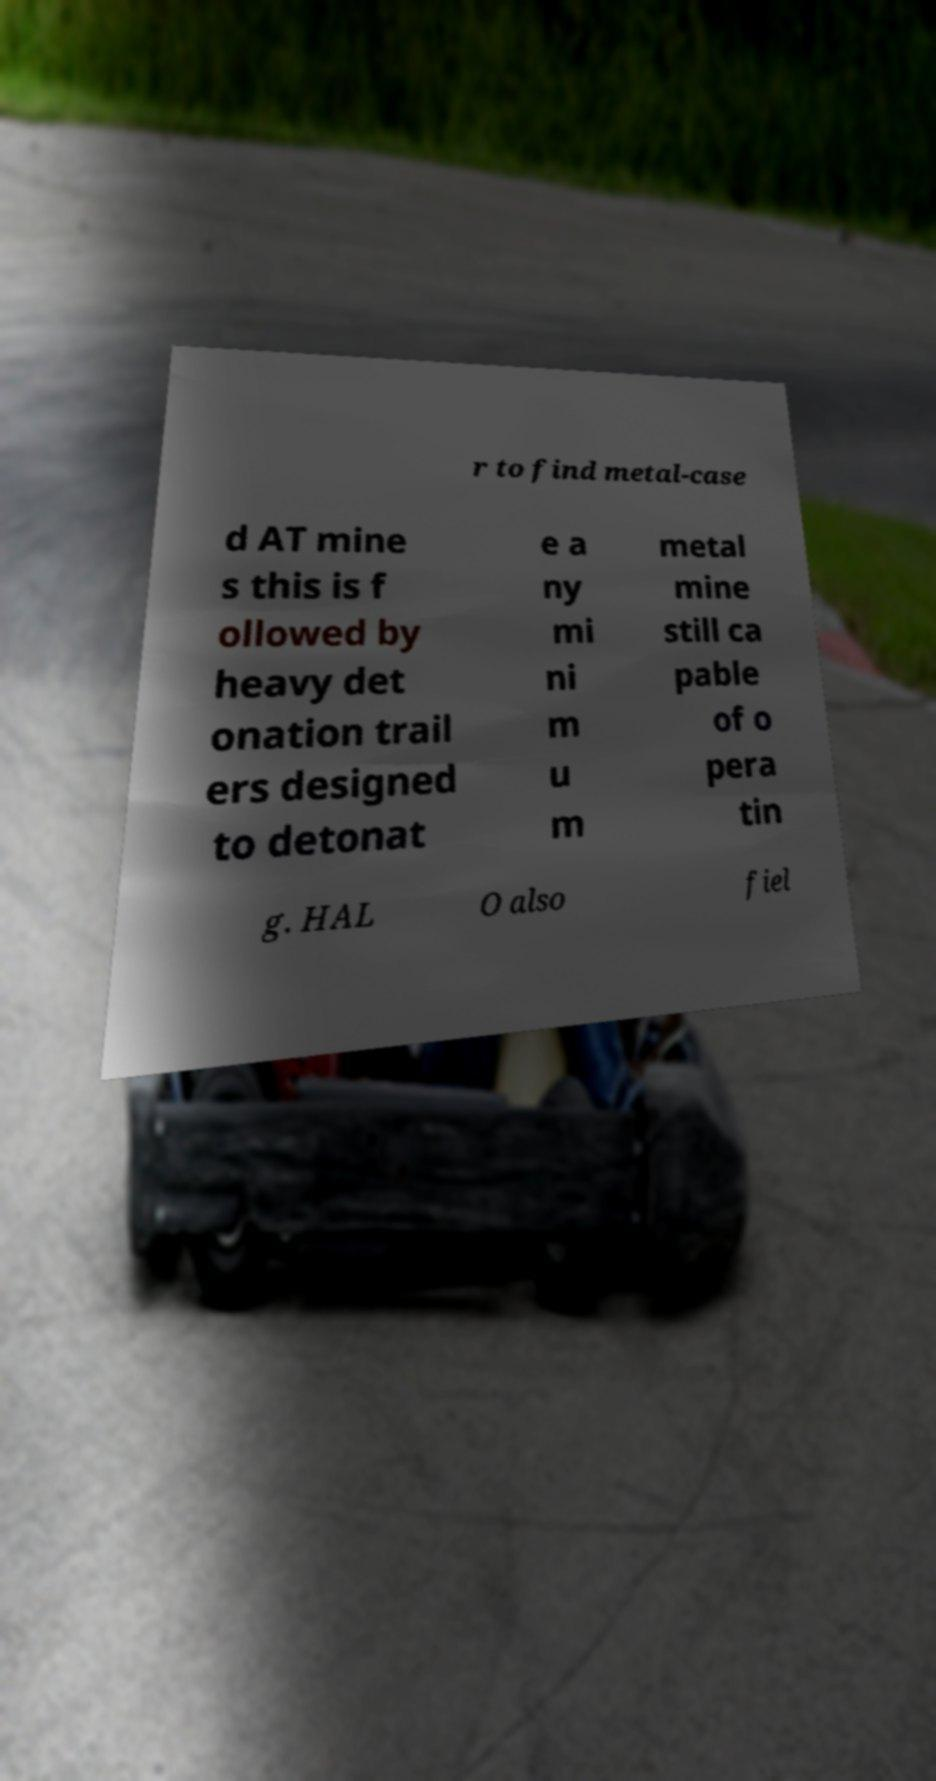Could you extract and type out the text from this image? r to find metal-case d AT mine s this is f ollowed by heavy det onation trail ers designed to detonat e a ny mi ni m u m metal mine still ca pable of o pera tin g. HAL O also fiel 